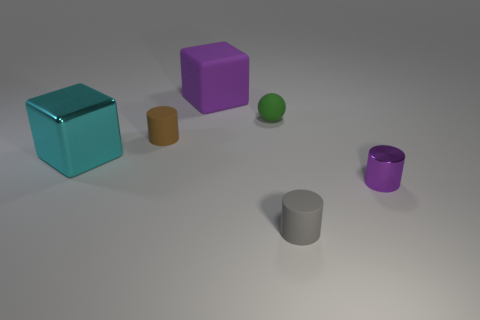Are there any other things that have the same shape as the green thing?
Offer a very short reply. No. Is there anything else that has the same size as the metallic block?
Ensure brevity in your answer.  Yes. What color is the large cube that is made of the same material as the tiny green thing?
Your response must be concise. Purple. The rubber cylinder that is in front of the cyan metallic block is what color?
Provide a succinct answer. Gray. How many large things have the same color as the large metal block?
Ensure brevity in your answer.  0. Are there fewer brown matte things in front of the small brown cylinder than tiny green rubber spheres that are to the right of the tiny purple metallic object?
Offer a very short reply. No. There is a tiny gray rubber object; how many blocks are in front of it?
Your answer should be very brief. 0. Is there a tiny green ball made of the same material as the big purple thing?
Offer a terse response. Yes. Is the number of things that are left of the small brown rubber object greater than the number of rubber blocks to the left of the big purple cube?
Give a very brief answer. Yes. The gray matte cylinder is what size?
Give a very brief answer. Small. 